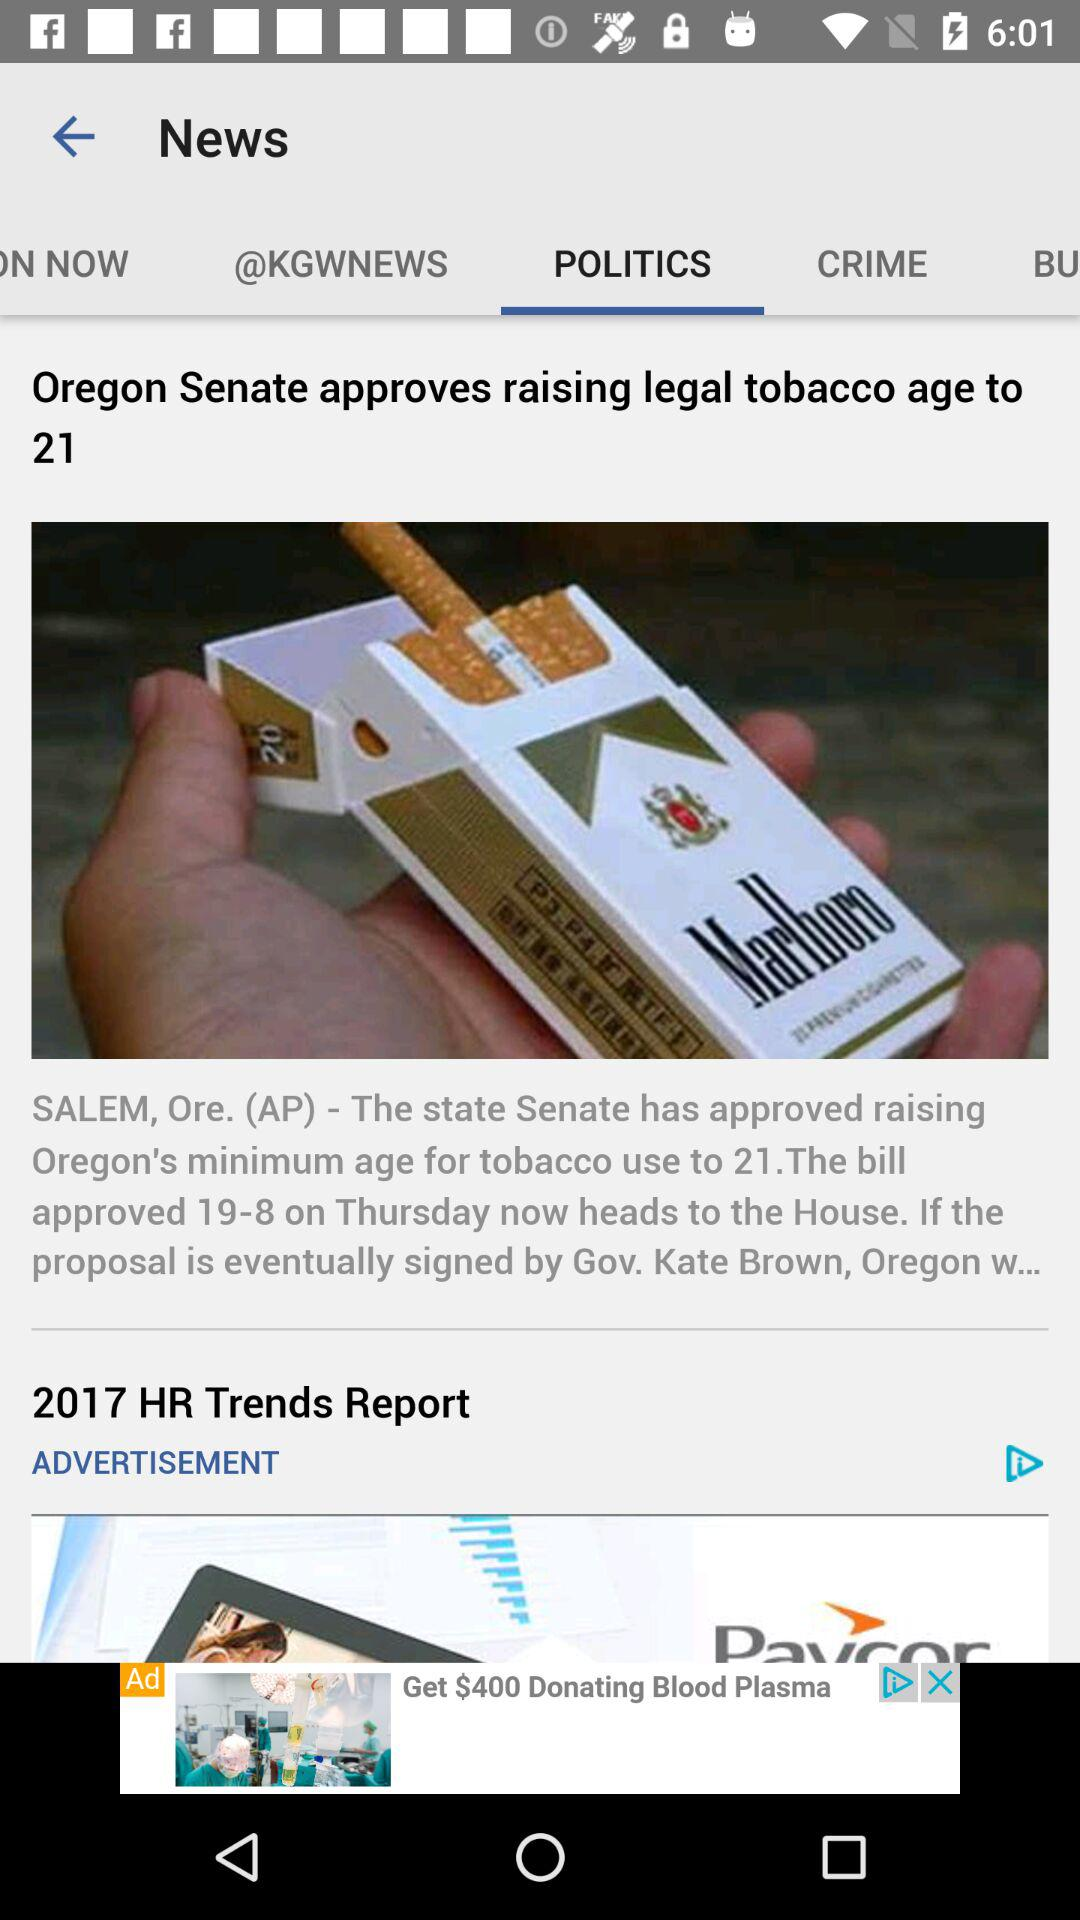Which tab is selected? The selected tab is "POLITICS". 